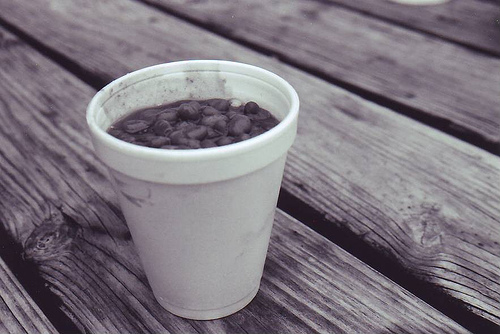<image>
Is the cup under the table? No. The cup is not positioned under the table. The vertical relationship between these objects is different. 